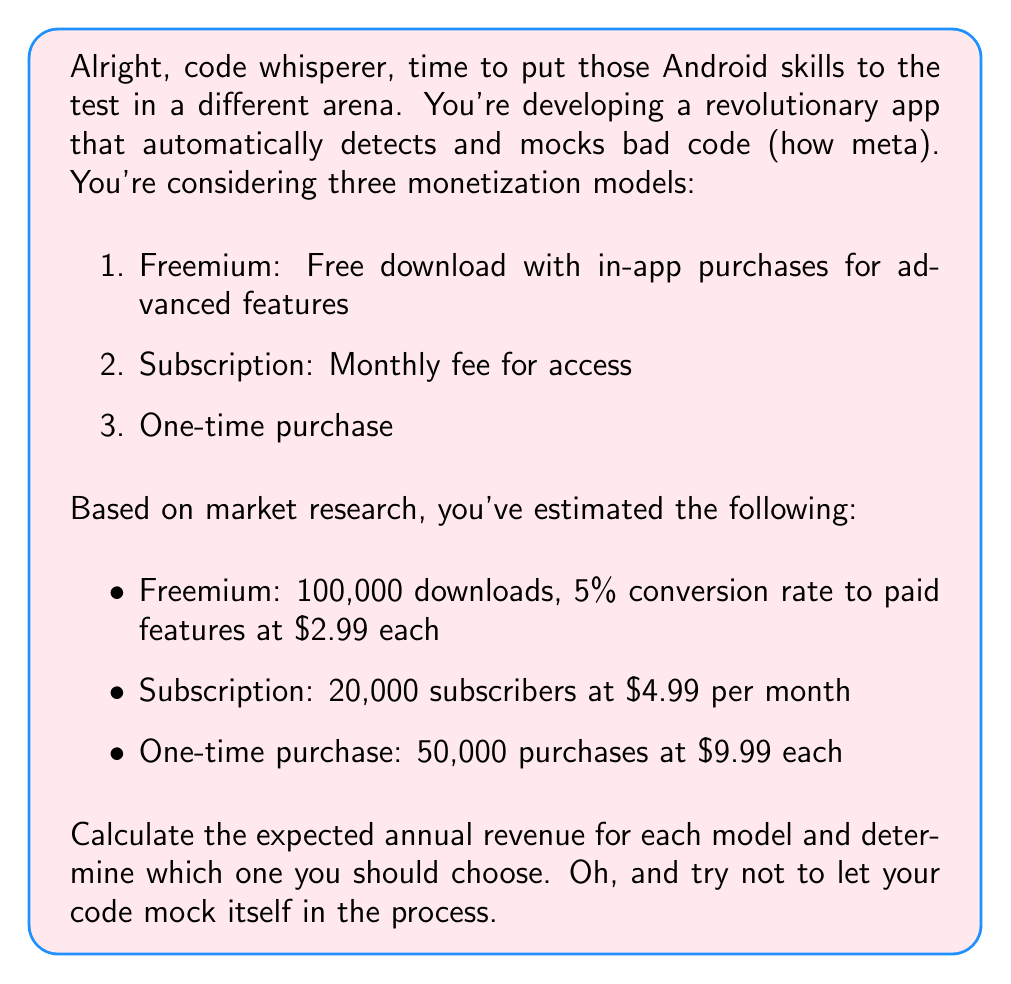Could you help me with this problem? Let's break this down step-by-step, shall we? Try to keep up, it's not as complex as debugging a race condition.

1. Freemium Model:
   - Total downloads: 100,000
   - Conversion rate: 5% = 0.05
   - Price of paid features: $2.99
   
   Expected Revenue = Downloads × Conversion Rate × Price
   $$R_{freemium} = 100,000 \times 0.05 \times \$2.99 = \$14,950$$

2. Subscription Model:
   - Subscribers: 20,000
   - Monthly fee: $4.99
   - Months in a year: 12
   
   Expected Annual Revenue = Subscribers × Monthly Fee × Months
   $$R_{subscription} = 20,000 \times \$4.99 \times 12 = \$1,197,600$$

3. One-time Purchase Model:
   - Purchases: 50,000
   - Price: $9.99
   
   Expected Revenue = Purchases × Price
   $$R_{one-time} = 50,000 \times \$9.99 = \$499,500$$

Now, let's compare these values:
$$R_{subscription} > R_{one-time} > R_{freemium}$$

$1,197,600 > 499,500 > 14,950$

Looks like the subscription model is the clear winner here, much like how Kotlin is clearly superior to Java (fight me).
Answer: The subscription model yields the highest expected annual revenue at $1,197,600, making it the optimal choice among the three monetization models presented. 